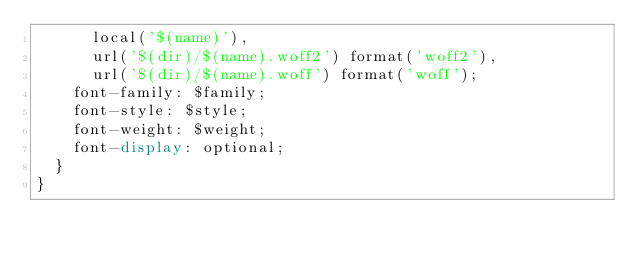Convert code to text. <code><loc_0><loc_0><loc_500><loc_500><_CSS_>      local('$(name)'),
      url('$(dir)/$(name).woff2') format('woff2'),
      url('$(dir)/$(name).woff') format('woff');
    font-family: $family;
    font-style: $style;
    font-weight: $weight;
    font-display: optional;
  }
}
</code> 